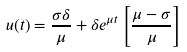Convert formula to latex. <formula><loc_0><loc_0><loc_500><loc_500>u ( t ) = \frac { \sigma \delta } { \mu } + \delta e ^ { \mu t } \left [ \frac { \mu - \sigma } { \mu } \right ]</formula> 